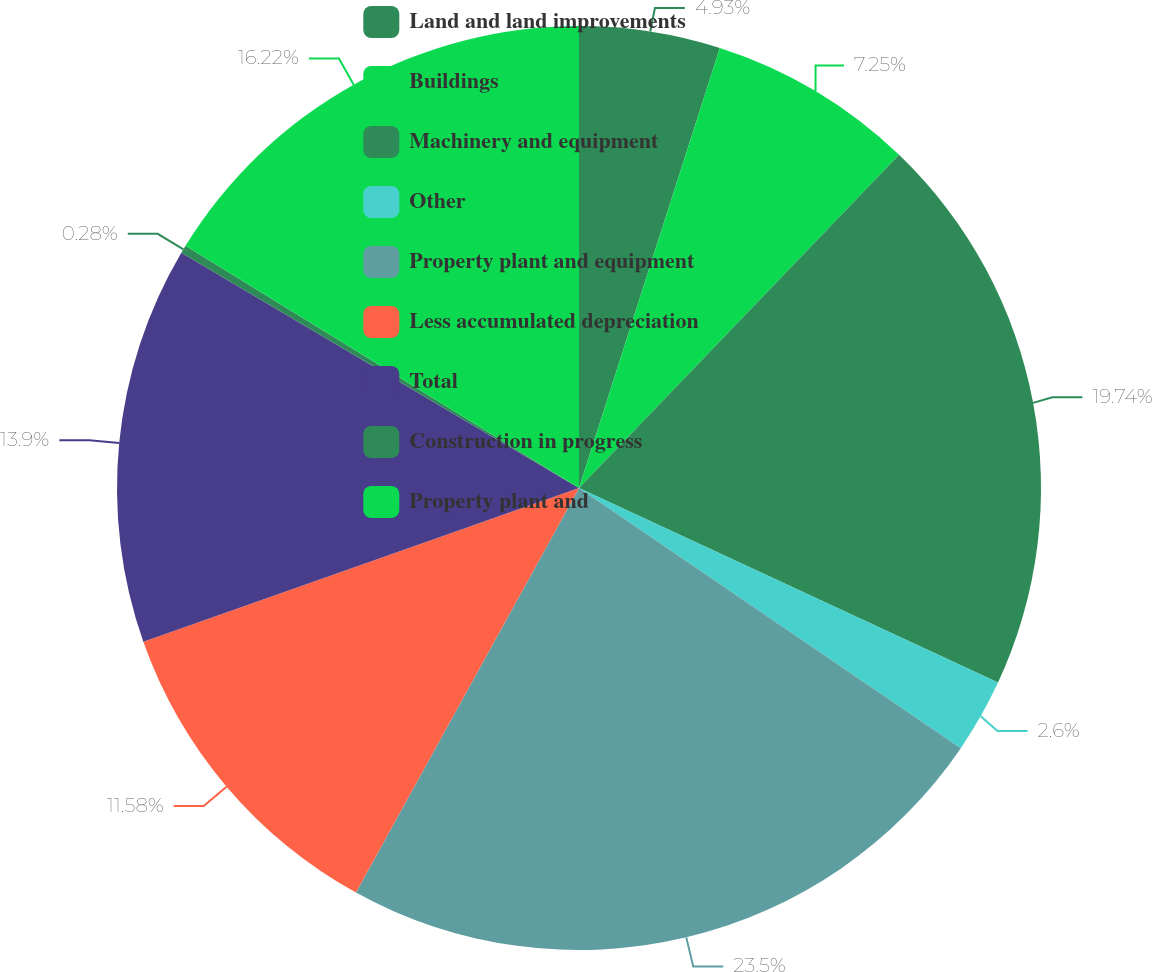Convert chart. <chart><loc_0><loc_0><loc_500><loc_500><pie_chart><fcel>Land and land improvements<fcel>Buildings<fcel>Machinery and equipment<fcel>Other<fcel>Property plant and equipment<fcel>Less accumulated depreciation<fcel>Total<fcel>Construction in progress<fcel>Property plant and<nl><fcel>4.93%<fcel>7.25%<fcel>19.74%<fcel>2.6%<fcel>23.5%<fcel>11.58%<fcel>13.9%<fcel>0.28%<fcel>16.22%<nl></chart> 